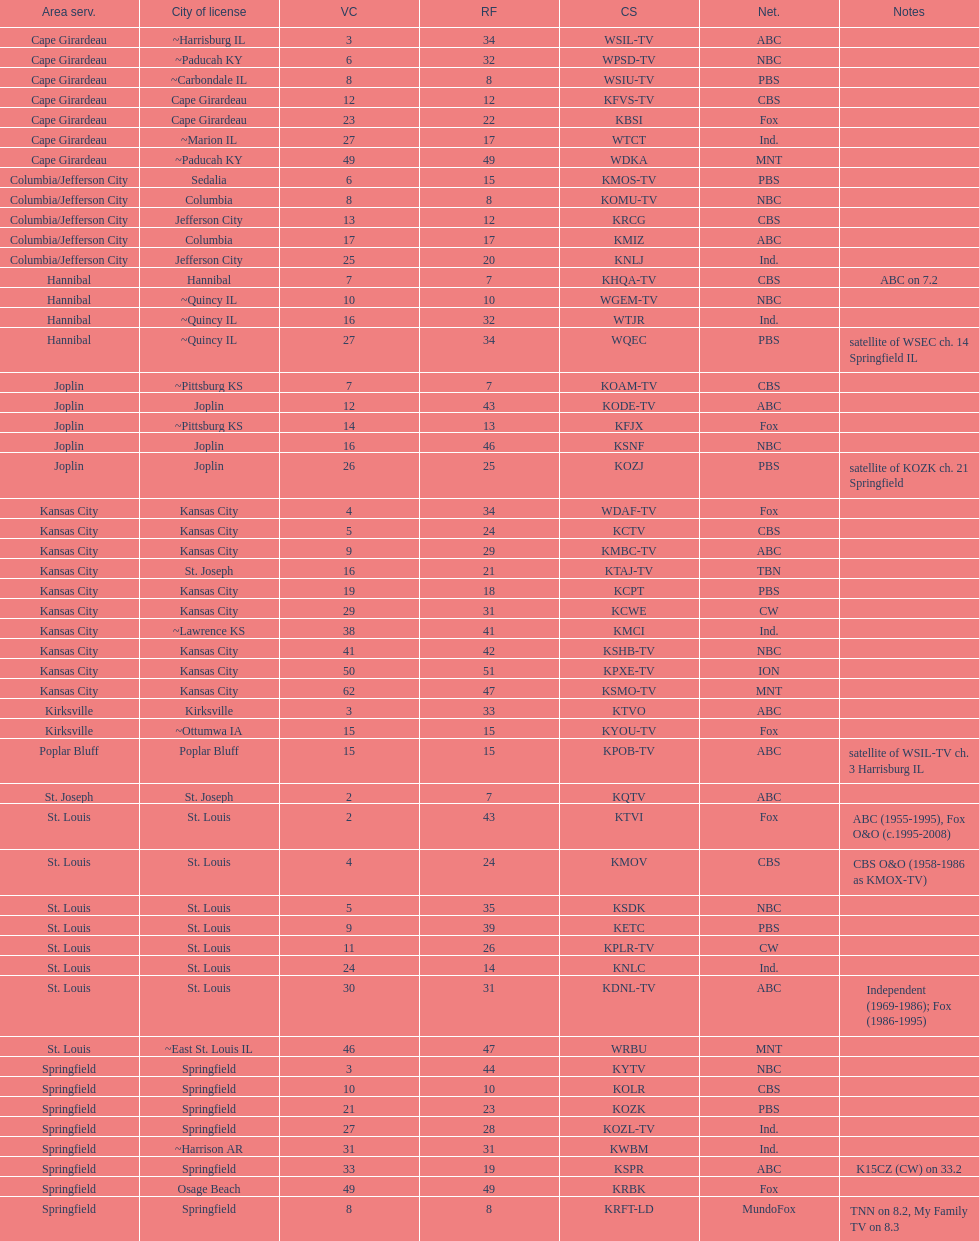How many are on the cbs network? 7. 